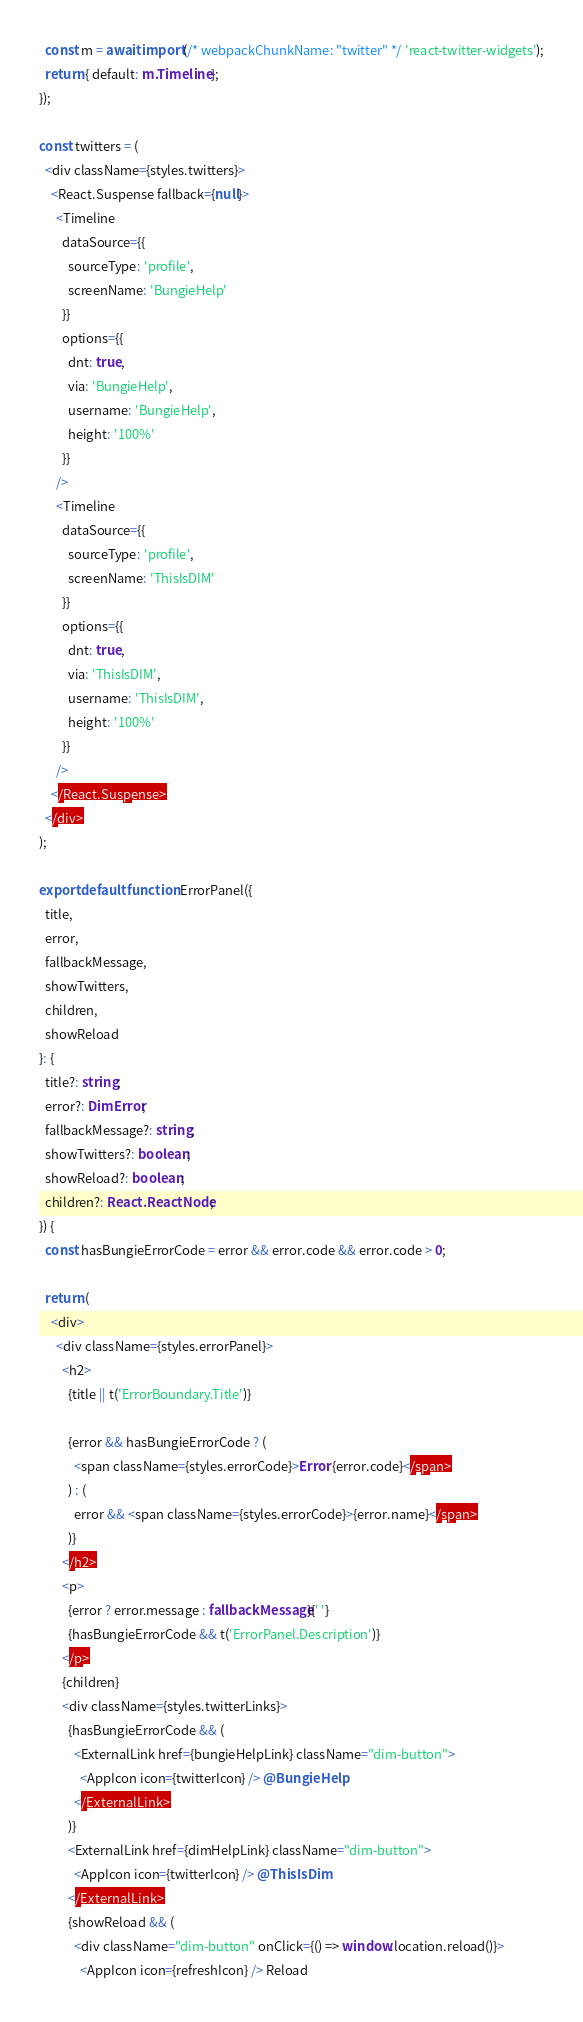<code> <loc_0><loc_0><loc_500><loc_500><_TypeScript_>  const m = await import(/* webpackChunkName: "twitter" */ 'react-twitter-widgets');
  return { default: m.Timeline };
});

const twitters = (
  <div className={styles.twitters}>
    <React.Suspense fallback={null}>
      <Timeline
        dataSource={{
          sourceType: 'profile',
          screenName: 'BungieHelp'
        }}
        options={{
          dnt: true,
          via: 'BungieHelp',
          username: 'BungieHelp',
          height: '100%'
        }}
      />
      <Timeline
        dataSource={{
          sourceType: 'profile',
          screenName: 'ThisIsDIM'
        }}
        options={{
          dnt: true,
          via: 'ThisIsDIM',
          username: 'ThisIsDIM',
          height: '100%'
        }}
      />
    </React.Suspense>
  </div>
);

export default function ErrorPanel({
  title,
  error,
  fallbackMessage,
  showTwitters,
  children,
  showReload
}: {
  title?: string;
  error?: DimError;
  fallbackMessage?: string;
  showTwitters?: boolean;
  showReload?: boolean;
  children?: React.ReactNode;
}) {
  const hasBungieErrorCode = error && error.code && error.code > 0;

  return (
    <div>
      <div className={styles.errorPanel}>
        <h2>
          {title || t('ErrorBoundary.Title')}

          {error && hasBungieErrorCode ? (
            <span className={styles.errorCode}>Error {error.code}</span>
          ) : (
            error && <span className={styles.errorCode}>{error.name}</span>
          )}
        </h2>
        <p>
          {error ? error.message : fallbackMessage}{' '}
          {hasBungieErrorCode && t('ErrorPanel.Description')}
        </p>
        {children}
        <div className={styles.twitterLinks}>
          {hasBungieErrorCode && (
            <ExternalLink href={bungieHelpLink} className="dim-button">
              <AppIcon icon={twitterIcon} /> @BungieHelp
            </ExternalLink>
          )}
          <ExternalLink href={dimHelpLink} className="dim-button">
            <AppIcon icon={twitterIcon} /> @ThisIsDim
          </ExternalLink>
          {showReload && (
            <div className="dim-button" onClick={() => window.location.reload()}>
              <AppIcon icon={refreshIcon} /> Reload</code> 